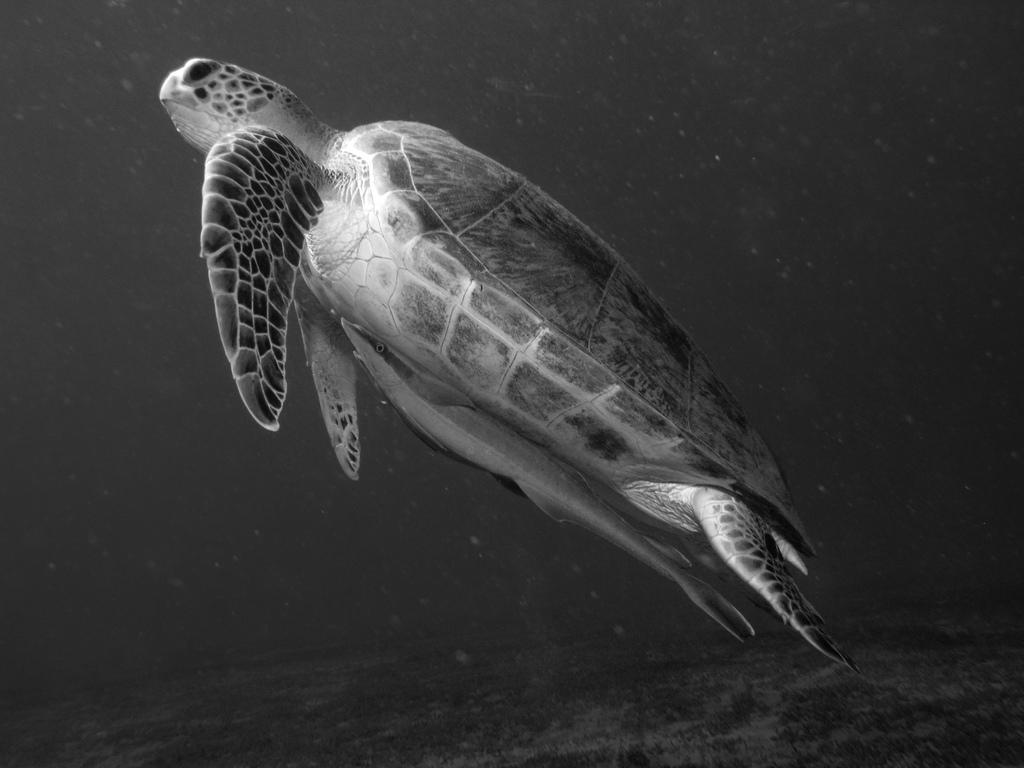Describe this image in one or two sentences. In this image I can see a turtle in the water. This image is taken may be in the ocean during night. 